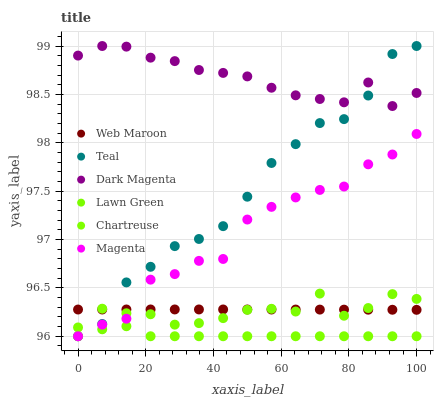Does Chartreuse have the minimum area under the curve?
Answer yes or no. Yes. Does Dark Magenta have the maximum area under the curve?
Answer yes or no. Yes. Does Web Maroon have the minimum area under the curve?
Answer yes or no. No. Does Web Maroon have the maximum area under the curve?
Answer yes or no. No. Is Web Maroon the smoothest?
Answer yes or no. Yes. Is Magenta the roughest?
Answer yes or no. Yes. Is Dark Magenta the smoothest?
Answer yes or no. No. Is Dark Magenta the roughest?
Answer yes or no. No. Does Lawn Green have the lowest value?
Answer yes or no. Yes. Does Web Maroon have the lowest value?
Answer yes or no. No. Does Teal have the highest value?
Answer yes or no. Yes. Does Web Maroon have the highest value?
Answer yes or no. No. Is Chartreuse less than Dark Magenta?
Answer yes or no. Yes. Is Dark Magenta greater than Web Maroon?
Answer yes or no. Yes. Does Chartreuse intersect Web Maroon?
Answer yes or no. Yes. Is Chartreuse less than Web Maroon?
Answer yes or no. No. Is Chartreuse greater than Web Maroon?
Answer yes or no. No. Does Chartreuse intersect Dark Magenta?
Answer yes or no. No. 